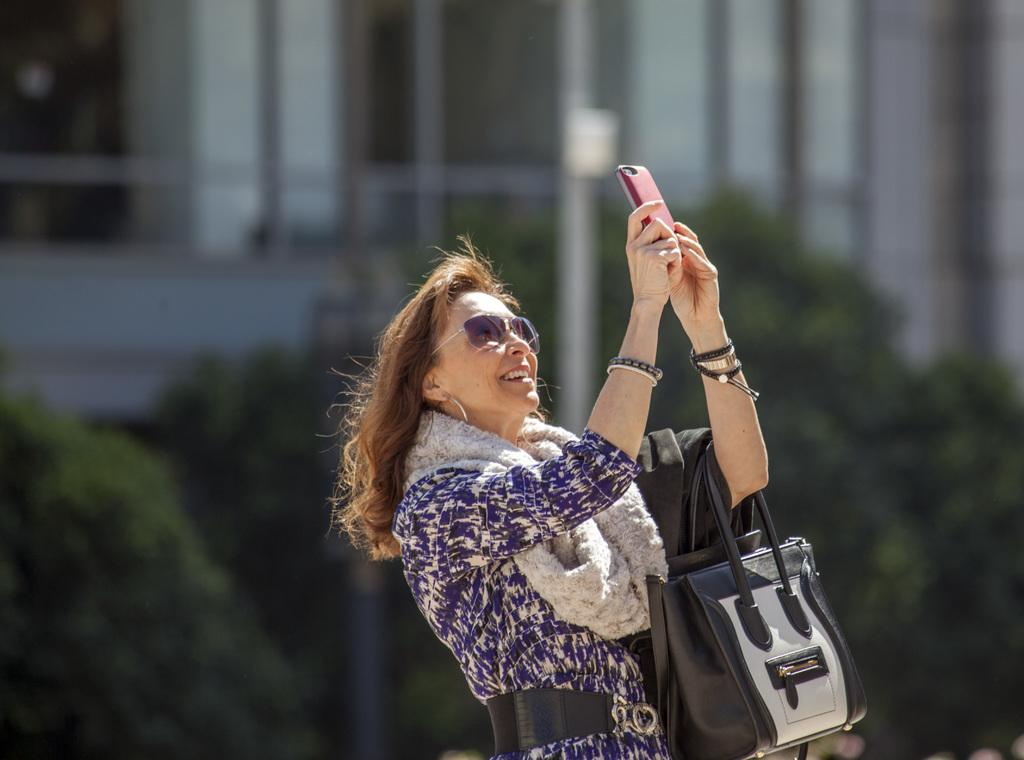Who is the main subject in the image? There is a woman in the image. What is the woman doing in the image? The woman is taking a selfie with her mobile. What can be seen in the background of the image? There is a pole, plants, and a building in the background of the image. What accessory is the woman wearing in the image? The woman is wearing glasses. What color is the balloon that the woman is holding in the image? There is no balloon present in the image; the woman is taking a selfie with her mobile. How does the woman's health appear to be in the image? The image does not provide any information about the woman's health, as it focuses on her taking a selfie. 